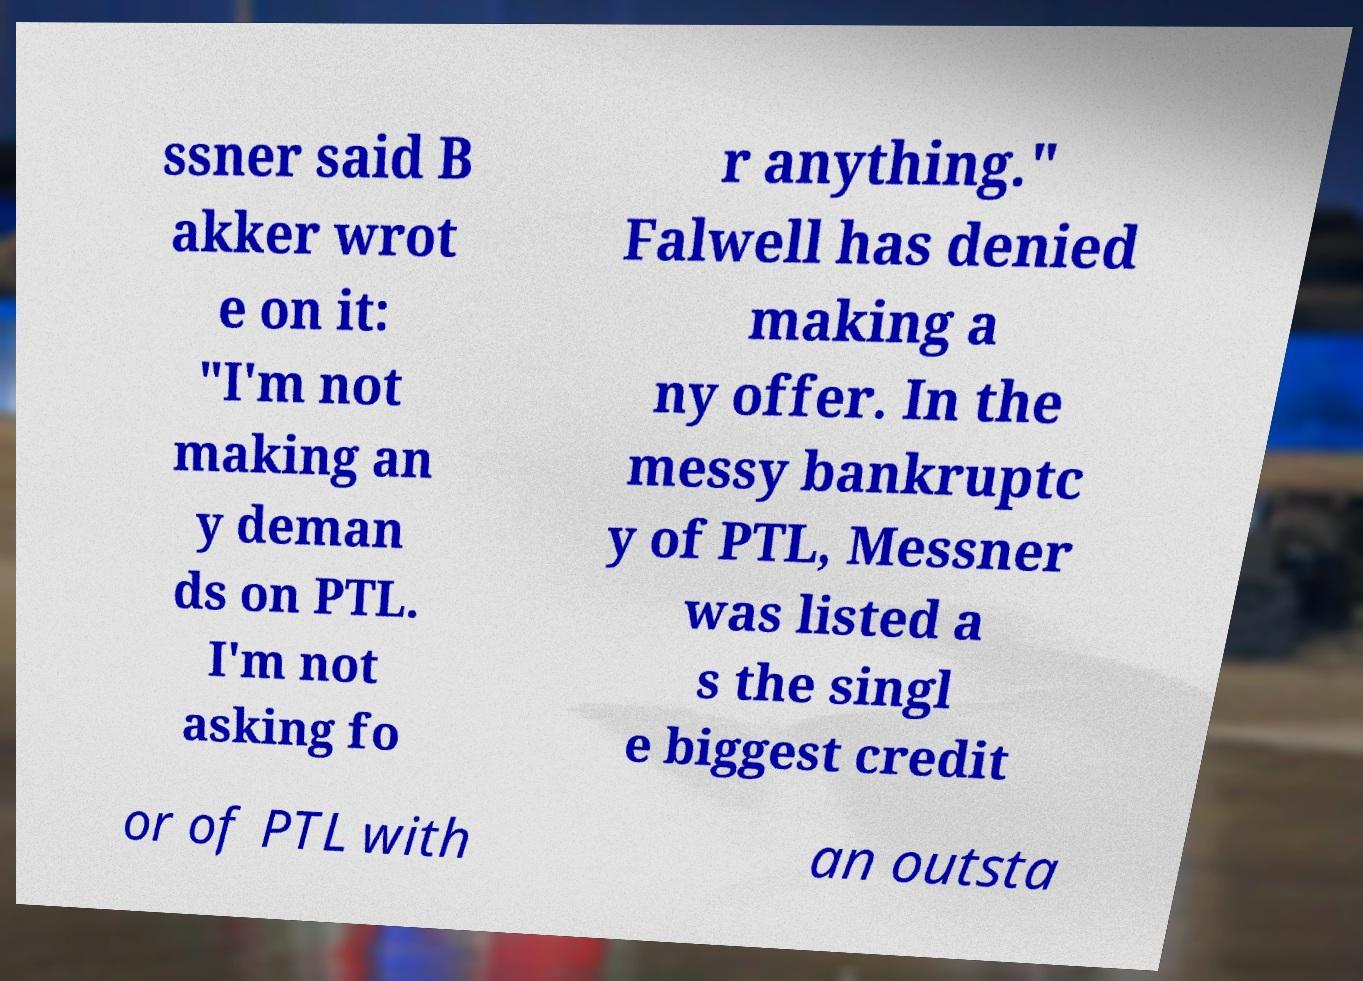What messages or text are displayed in this image? I need them in a readable, typed format. ssner said B akker wrot e on it: "I'm not making an y deman ds on PTL. I'm not asking fo r anything." Falwell has denied making a ny offer. In the messy bankruptc y of PTL, Messner was listed a s the singl e biggest credit or of PTL with an outsta 